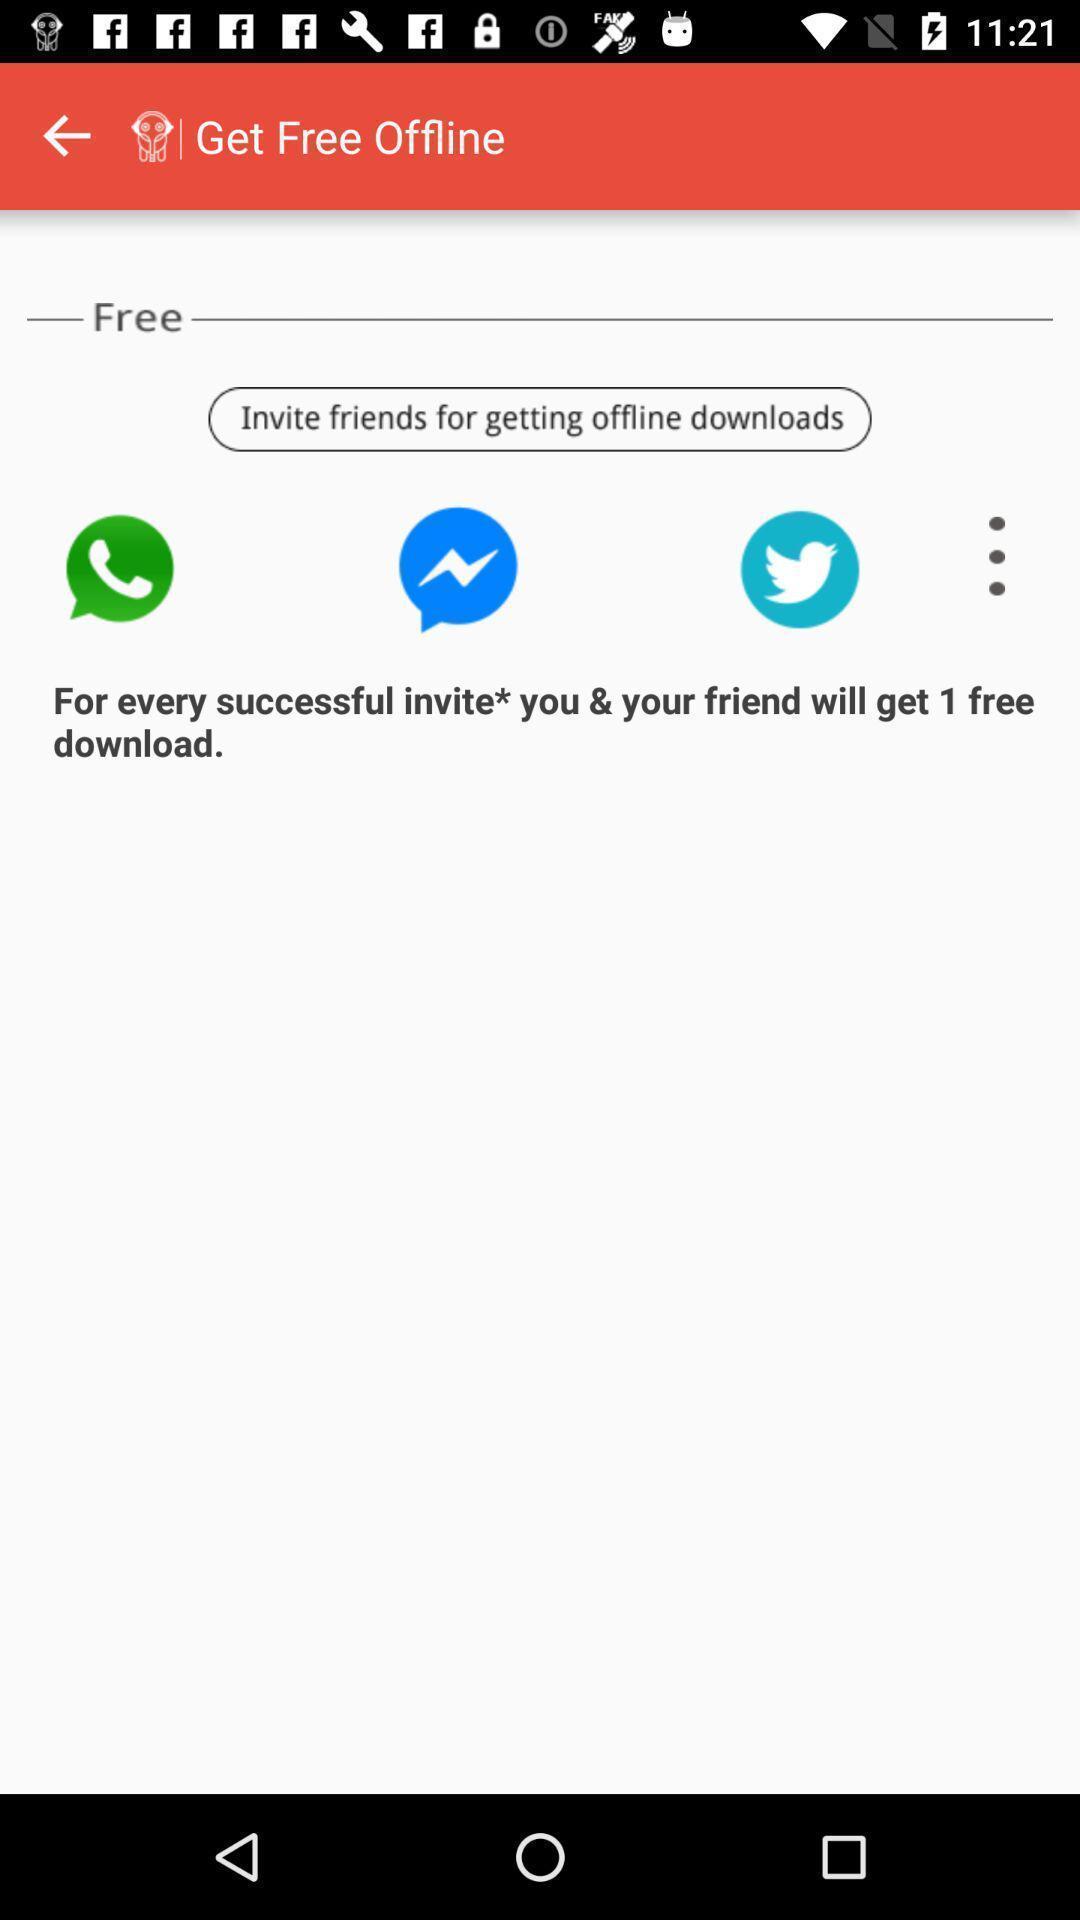Please provide a description for this image. Screen displaying multiple social icons in a music application. 